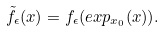Convert formula to latex. <formula><loc_0><loc_0><loc_500><loc_500>\tilde { f } _ { \epsilon } ( x ) = f _ { \epsilon } ( e x p _ { x _ { 0 } } ( x ) ) .</formula> 